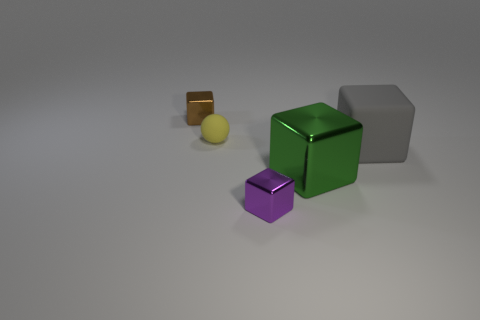What materials do the objects seem to be made of? Based on the image, the objects appear to have varying materials. The large gray one looks like it could be made out of a matte plastic or concrete, the green has a shiny metallic finish suggesting it might be metal, while the brown and purple objects seem to exhibit metallic characteristics as well, and the small yellow object has a surface that might imply a rubbery texture. 